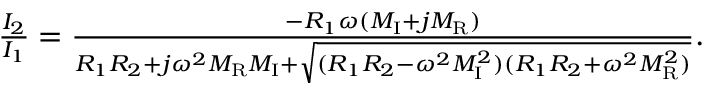<formula> <loc_0><loc_0><loc_500><loc_500>\begin{array} { r } { \frac { I _ { 2 } } { I _ { 1 } } = \frac { - R _ { 1 } \omega ( M _ { I } + j M _ { R } ) } { R _ { 1 } R _ { 2 } + j \omega ^ { 2 } M _ { R } M _ { I } + \sqrt { ( R _ { 1 } R _ { 2 } - \omega ^ { 2 } M _ { I } ^ { 2 } ) ( R _ { 1 } R _ { 2 } + \omega ^ { 2 } M _ { R } ^ { 2 } ) } } . } \end{array}</formula> 